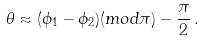Convert formula to latex. <formula><loc_0><loc_0><loc_500><loc_500>\theta \approx ( \phi _ { 1 } - \phi _ { 2 } ) ( m o d \pi ) - \frac { \pi } { 2 } \, .</formula> 